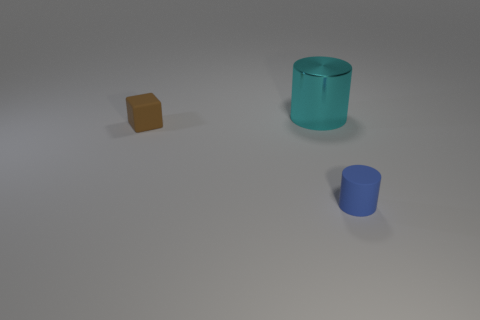Add 1 big cyan metallic cylinders. How many objects exist? 4 Subtract all cylinders. How many objects are left? 1 Add 3 blue matte things. How many blue matte things exist? 4 Subtract 0 purple blocks. How many objects are left? 3 Subtract all tiny gray metallic cylinders. Subtract all shiny cylinders. How many objects are left? 2 Add 2 matte cylinders. How many matte cylinders are left? 3 